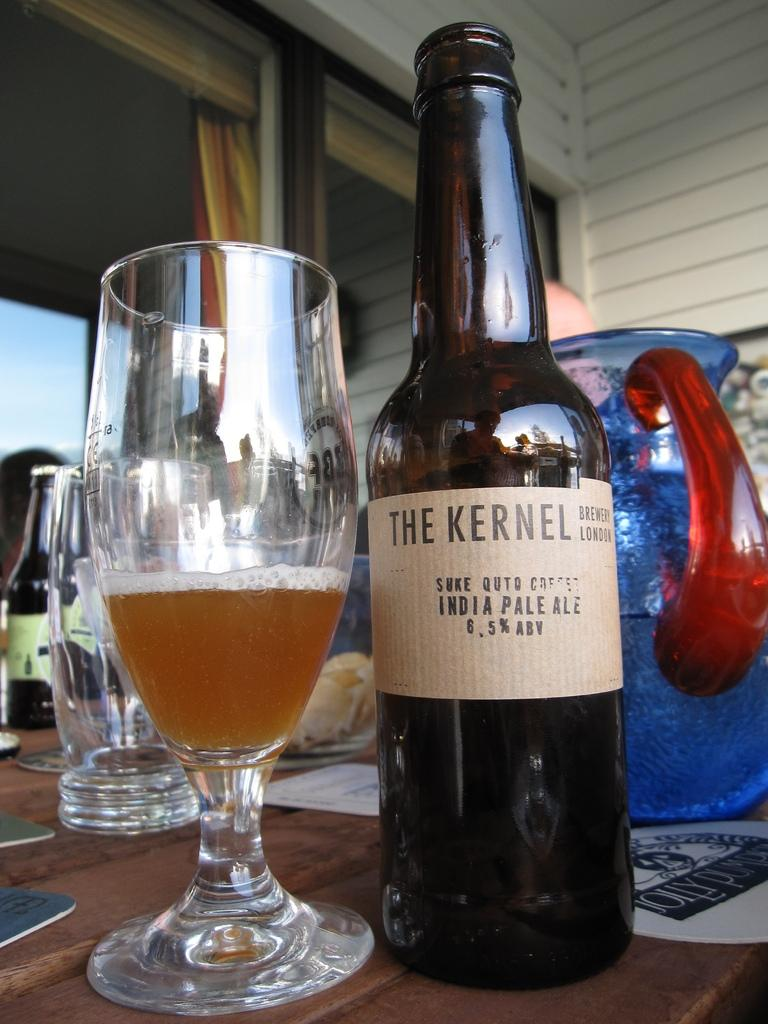<image>
Provide a brief description of the given image. Some The Kernel India Pale Ale has been poured into a glass. 